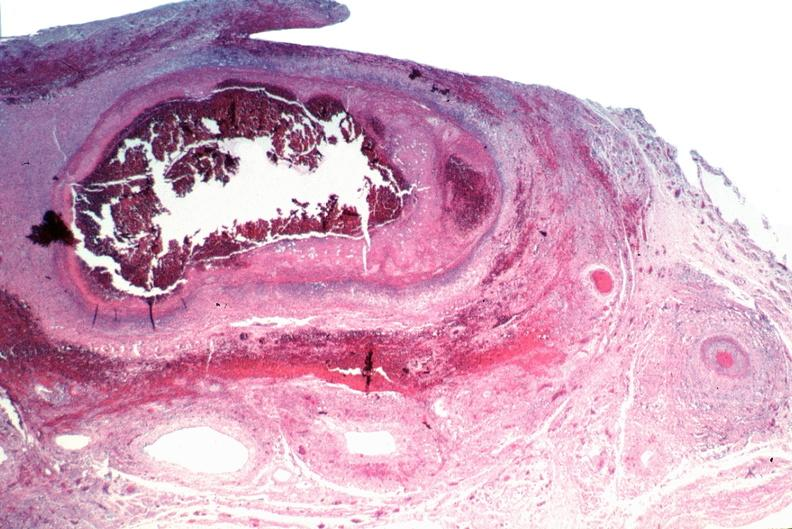where is this from?
Answer the question using a single word or phrase. Vasculature 